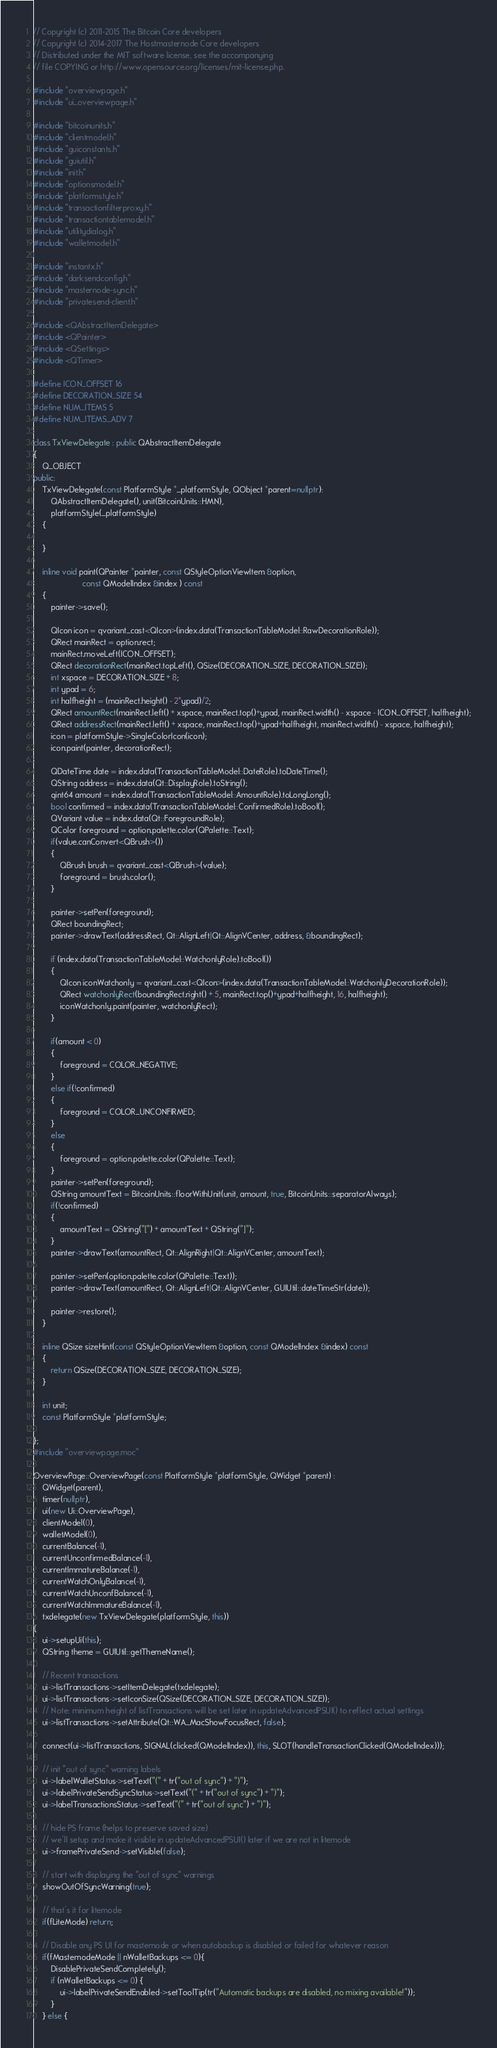<code> <loc_0><loc_0><loc_500><loc_500><_C++_>// Copyright (c) 2011-2015 The Bitcoin Core developers
// Copyright (c) 2014-2017 The Hostmasternode Core developers
// Distributed under the MIT software license, see the accompanying
// file COPYING or http://www.opensource.org/licenses/mit-license.php.

#include "overviewpage.h"
#include "ui_overviewpage.h"

#include "bitcoinunits.h"
#include "clientmodel.h"
#include "guiconstants.h"
#include "guiutil.h"
#include "init.h"
#include "optionsmodel.h"
#include "platformstyle.h"
#include "transactionfilterproxy.h"
#include "transactiontablemodel.h"
#include "utilitydialog.h"
#include "walletmodel.h"

#include "instantx.h"
#include "darksendconfig.h"
#include "masternode-sync.h"
#include "privatesend-client.h"

#include <QAbstractItemDelegate>
#include <QPainter>
#include <QSettings>
#include <QTimer>

#define ICON_OFFSET 16
#define DECORATION_SIZE 54
#define NUM_ITEMS 5
#define NUM_ITEMS_ADV 7

class TxViewDelegate : public QAbstractItemDelegate
{
    Q_OBJECT
public:
    TxViewDelegate(const PlatformStyle *_platformStyle, QObject *parent=nullptr):
        QAbstractItemDelegate(), unit(BitcoinUnits::HMN),
        platformStyle(_platformStyle)
    {

    }

    inline void paint(QPainter *painter, const QStyleOptionViewItem &option,
                      const QModelIndex &index ) const
    {
        painter->save();

        QIcon icon = qvariant_cast<QIcon>(index.data(TransactionTableModel::RawDecorationRole));
        QRect mainRect = option.rect;
        mainRect.moveLeft(ICON_OFFSET);
        QRect decorationRect(mainRect.topLeft(), QSize(DECORATION_SIZE, DECORATION_SIZE));
        int xspace = DECORATION_SIZE + 8;
        int ypad = 6;
        int halfheight = (mainRect.height() - 2*ypad)/2;
        QRect amountRect(mainRect.left() + xspace, mainRect.top()+ypad, mainRect.width() - xspace - ICON_OFFSET, halfheight);
        QRect addressRect(mainRect.left() + xspace, mainRect.top()+ypad+halfheight, mainRect.width() - xspace, halfheight);
        icon = platformStyle->SingleColorIcon(icon);
        icon.paint(painter, decorationRect);

        QDateTime date = index.data(TransactionTableModel::DateRole).toDateTime();
        QString address = index.data(Qt::DisplayRole).toString();
        qint64 amount = index.data(TransactionTableModel::AmountRole).toLongLong();
        bool confirmed = index.data(TransactionTableModel::ConfirmedRole).toBool();
        QVariant value = index.data(Qt::ForegroundRole);
        QColor foreground = option.palette.color(QPalette::Text);
        if(value.canConvert<QBrush>())
        {
            QBrush brush = qvariant_cast<QBrush>(value);
            foreground = brush.color();
        }

        painter->setPen(foreground);
        QRect boundingRect;
        painter->drawText(addressRect, Qt::AlignLeft|Qt::AlignVCenter, address, &boundingRect);

        if (index.data(TransactionTableModel::WatchonlyRole).toBool())
        {
            QIcon iconWatchonly = qvariant_cast<QIcon>(index.data(TransactionTableModel::WatchonlyDecorationRole));
            QRect watchonlyRect(boundingRect.right() + 5, mainRect.top()+ypad+halfheight, 16, halfheight);
            iconWatchonly.paint(painter, watchonlyRect);
        }

        if(amount < 0)
        {
            foreground = COLOR_NEGATIVE;
        }
        else if(!confirmed)
        {
            foreground = COLOR_UNCONFIRMED;
        }
        else
        {
            foreground = option.palette.color(QPalette::Text);
        }
        painter->setPen(foreground);
        QString amountText = BitcoinUnits::floorWithUnit(unit, amount, true, BitcoinUnits::separatorAlways);
        if(!confirmed)
        {
            amountText = QString("[") + amountText + QString("]");
        }
        painter->drawText(amountRect, Qt::AlignRight|Qt::AlignVCenter, amountText);

        painter->setPen(option.palette.color(QPalette::Text));
        painter->drawText(amountRect, Qt::AlignLeft|Qt::AlignVCenter, GUIUtil::dateTimeStr(date));

        painter->restore();
    }

    inline QSize sizeHint(const QStyleOptionViewItem &option, const QModelIndex &index) const
    {
        return QSize(DECORATION_SIZE, DECORATION_SIZE);
    }

    int unit;
    const PlatformStyle *platformStyle;

};
#include "overviewpage.moc"

OverviewPage::OverviewPage(const PlatformStyle *platformStyle, QWidget *parent) :
    QWidget(parent),
    timer(nullptr),
    ui(new Ui::OverviewPage),
    clientModel(0),
    walletModel(0),
    currentBalance(-1),
    currentUnconfirmedBalance(-1),
    currentImmatureBalance(-1),
    currentWatchOnlyBalance(-1),
    currentWatchUnconfBalance(-1),
    currentWatchImmatureBalance(-1),
    txdelegate(new TxViewDelegate(platformStyle, this))
{
    ui->setupUi(this);
    QString theme = GUIUtil::getThemeName();

    // Recent transactions
    ui->listTransactions->setItemDelegate(txdelegate);
    ui->listTransactions->setIconSize(QSize(DECORATION_SIZE, DECORATION_SIZE));
    // Note: minimum height of listTransactions will be set later in updateAdvancedPSUI() to reflect actual settings
    ui->listTransactions->setAttribute(Qt::WA_MacShowFocusRect, false);

    connect(ui->listTransactions, SIGNAL(clicked(QModelIndex)), this, SLOT(handleTransactionClicked(QModelIndex)));

    // init "out of sync" warning labels
    ui->labelWalletStatus->setText("(" + tr("out of sync") + ")");
    ui->labelPrivateSendSyncStatus->setText("(" + tr("out of sync") + ")");
    ui->labelTransactionsStatus->setText("(" + tr("out of sync") + ")");

    // hide PS frame (helps to preserve saved size)
    // we'll setup and make it visible in updateAdvancedPSUI() later if we are not in litemode
    ui->framePrivateSend->setVisible(false);

    // start with displaying the "out of sync" warnings
    showOutOfSyncWarning(true);

    // that's it for litemode
    if(fLiteMode) return;

    // Disable any PS UI for masternode or when autobackup is disabled or failed for whatever reason
    if(fMasternodeMode || nWalletBackups <= 0){
        DisablePrivateSendCompletely();
        if (nWalletBackups <= 0) {
            ui->labelPrivateSendEnabled->setToolTip(tr("Automatic backups are disabled, no mixing available!"));
        }
    } else {</code> 